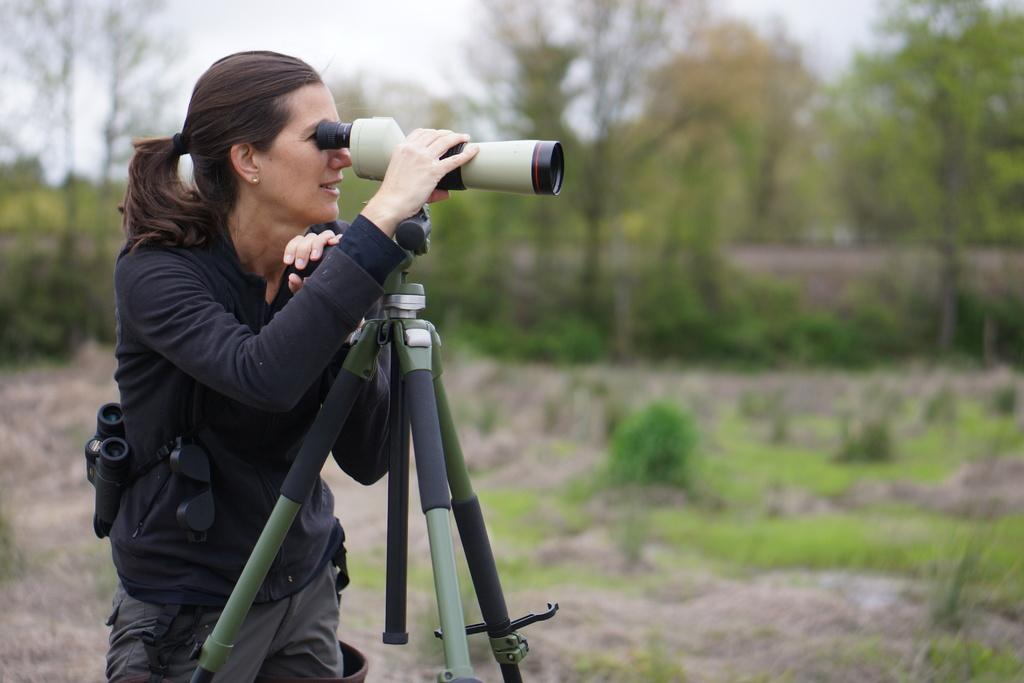Who is the main subject in the image? There is a woman in the image. What is the woman wearing? The woman is wearing a black and ash color dress. What is the woman holding in the image? The woman is holding a camera. What can be seen in the background of the image? There are trees in the image, and the background is blurred. What object is present in the image that might be used for support or display? There is a stand in the image. What type of caption is written on the woman's dress in the image? There is no caption written on the woman's dress in the image; it is a black and ash color dress. What type of polish is visible on the woman's nails in the image? There is no polish visible on the woman's nails in the image, as her hands are not shown. 